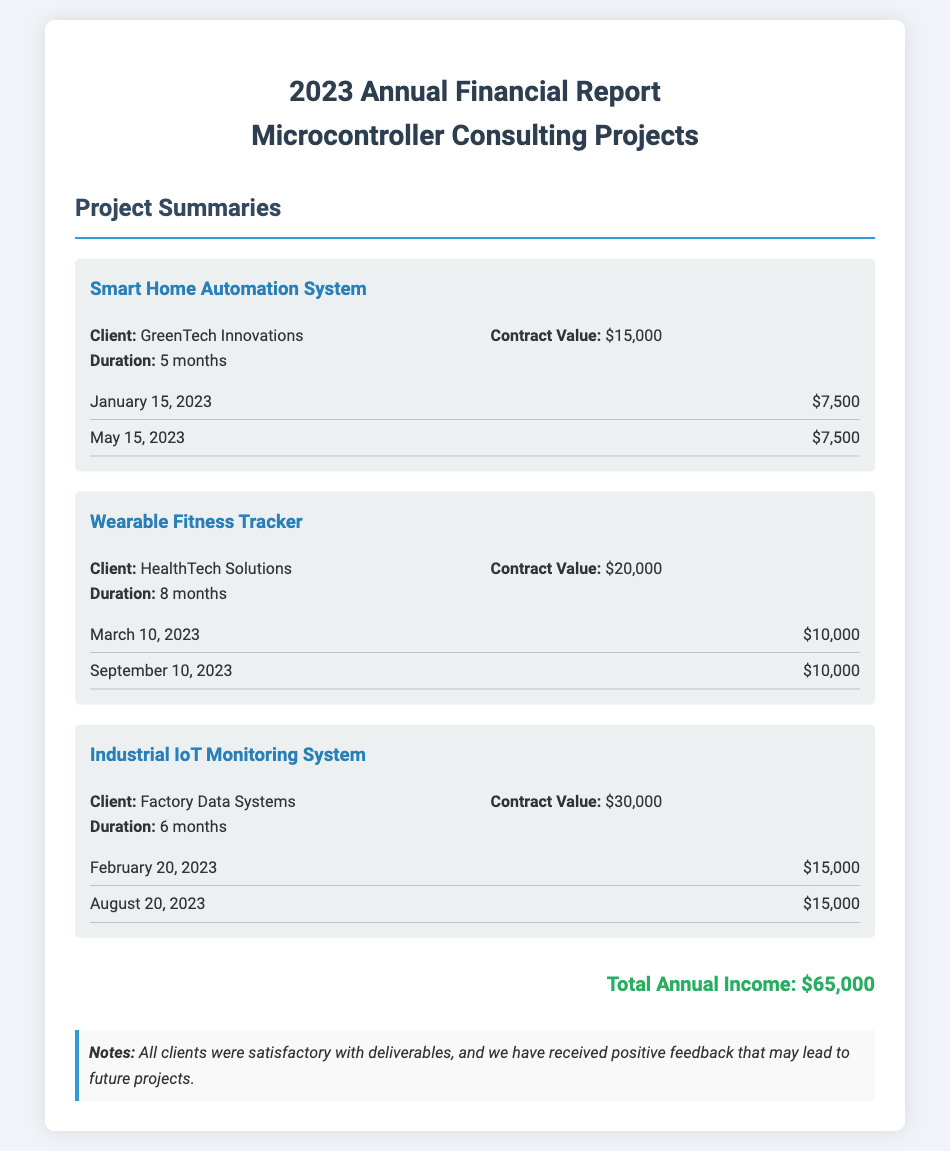What is the total annual income? The total annual income is explicitly stated at the bottom of the document as $65,000.
Answer: $65,000 Who is the client for the "Smart Home Automation System"? The document provides the client name for this project in the project summaries section, which is GreenTech Innovations.
Answer: GreenTech Innovations What was the contract value for the "Wearable Fitness Tracker"? The contract value is mentioned in the project details for this project, which is $20,000.
Answer: $20,000 How long did the "Industrial IoT Monitoring System" project last? The duration of this project is provided in the project details, which states it lasted for 6 months.
Answer: 6 months When was the last payment received for the "Wearable Fitness Tracker" project? The document specifies the payment dates under the payments section, indicating the last payment was on September 10, 2023.
Answer: September 10, 2023 Which project had the highest contract value? The document lists the contract values, and the highest one is for the Industrial IoT Monitoring System, which is $30,000.
Answer: $30,000 How many payments were made for the "Smart Home Automation System"? The payments section lists two payments made for this project, indicating the total number is 2.
Answer: 2 What feedback did clients give regarding the deliverables? The notes at the bottom of the document mention that all clients were satisfactory with deliverables.
Answer: Satisfactory Which client engaged for the "Industrial IoT Monitoring System"? The provided details list Factory Data Systems as the client for this project.
Answer: Factory Data Systems 